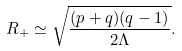<formula> <loc_0><loc_0><loc_500><loc_500>R _ { + } \simeq \sqrt { \frac { ( p + q ) ( q - 1 ) } { 2 \Lambda } } .</formula> 